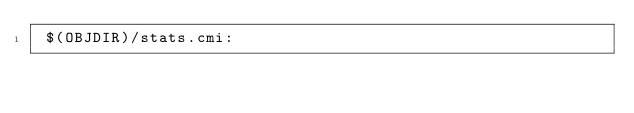Convert code to text. <code><loc_0><loc_0><loc_500><loc_500><_D_> $(OBJDIR)/stats.cmi:
</code> 